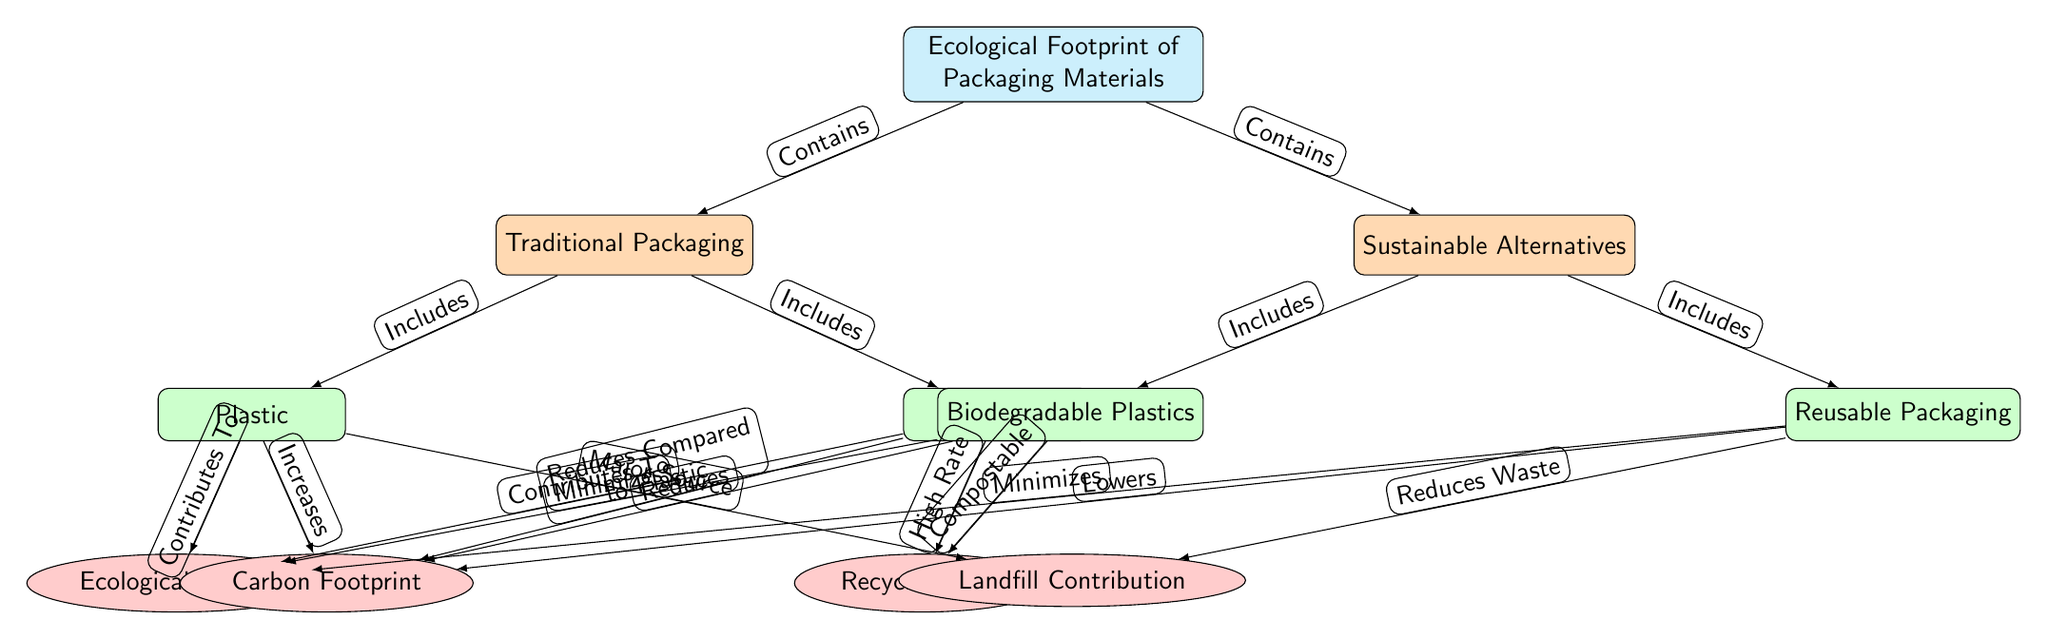What is the main focus of the diagram? The main focus of the diagram is shown in the central node labeled "Ecological Footprint of Packaging Materials". This node encapsulates the primary theme discussed in the diagram.
Answer: Ecological Footprint of Packaging Materials How many subcategories are listed under Sustainable Alternatives? There are two subcategories listed under Sustainable Alternatives: "Biodegradable Plastics" and "Reusable Packaging". This can be counted from the nodes falling under the "Sustainable Alternatives" category.
Answer: 2 What impacts does Traditional Packaging have on the environment according to the diagram? Traditional Packaging contributes to ecological impacts, increases carbon footprints, and is a major source of landfill contribution. Each of these relationships is indicated by the arrows pointing from the subcategories of Traditional Packaging to their respective impact nodes.
Answer: Ecological Impact, Carbon Footprint, Landfill Contribution Which packaging type has a high recycling rate? The packaging type "Paper" under the Traditional Packaging category is indicated to have a high recycling rate, as stated in the connection from the Paper subcategory to its corresponding impact node.
Answer: Paper What connection exists between Biodegradable Plastics and ecological impact? Biodegradable Plastics is shown to minimize ecological impact. This relationship is indicated by the arrow connecting the subcategory of Biodegradable Plastics to its impact node within the diagram.
Answer: Minimizes Which category includes "Plastic" as a subcategory? The "Traditional Packaging" category includes "Plastic" as one of its subcategories as indicated in the diagram by the relationship arrows.
Answer: Traditional Packaging Which subcategory decreases carbon footprint compared to Plastic? The subcategory "Biodegradable Plastics" is shown to reduce carbon footprint compared to Plastic according to the relationship indicated in the diagram.
Answer: Biodegradable Plastics How many edges connect the "Ecological Footprint of Packaging Materials" to its categories? There are two edges that connect the main node "Ecological Footprint of Packaging Materials" to its categories, which are "Traditional Packaging" and "Sustainable Alternatives". This can be confirmed by counting the arrows originating from the main node.
Answer: 2 Which subcategory is associated with reducing waste? The "Reusable Packaging" subcategory is connected to the impact of reducing waste as specified in the diagram’s relationships.
Answer: Reusable Packaging 